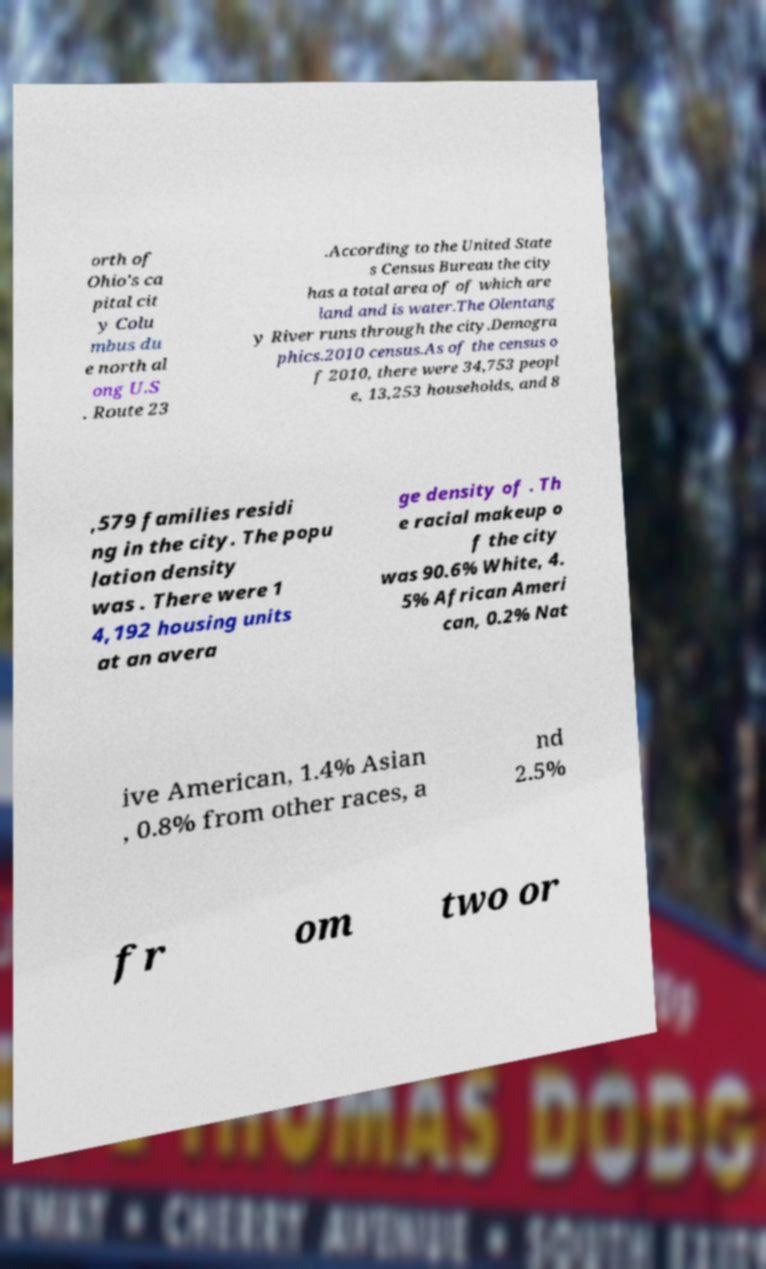I need the written content from this picture converted into text. Can you do that? orth of Ohio's ca pital cit y Colu mbus du e north al ong U.S . Route 23 .According to the United State s Census Bureau the city has a total area of of which are land and is water.The Olentang y River runs through the city.Demogra phics.2010 census.As of the census o f 2010, there were 34,753 peopl e, 13,253 households, and 8 ,579 families residi ng in the city. The popu lation density was . There were 1 4,192 housing units at an avera ge density of . Th e racial makeup o f the city was 90.6% White, 4. 5% African Ameri can, 0.2% Nat ive American, 1.4% Asian , 0.8% from other races, a nd 2.5% fr om two or 